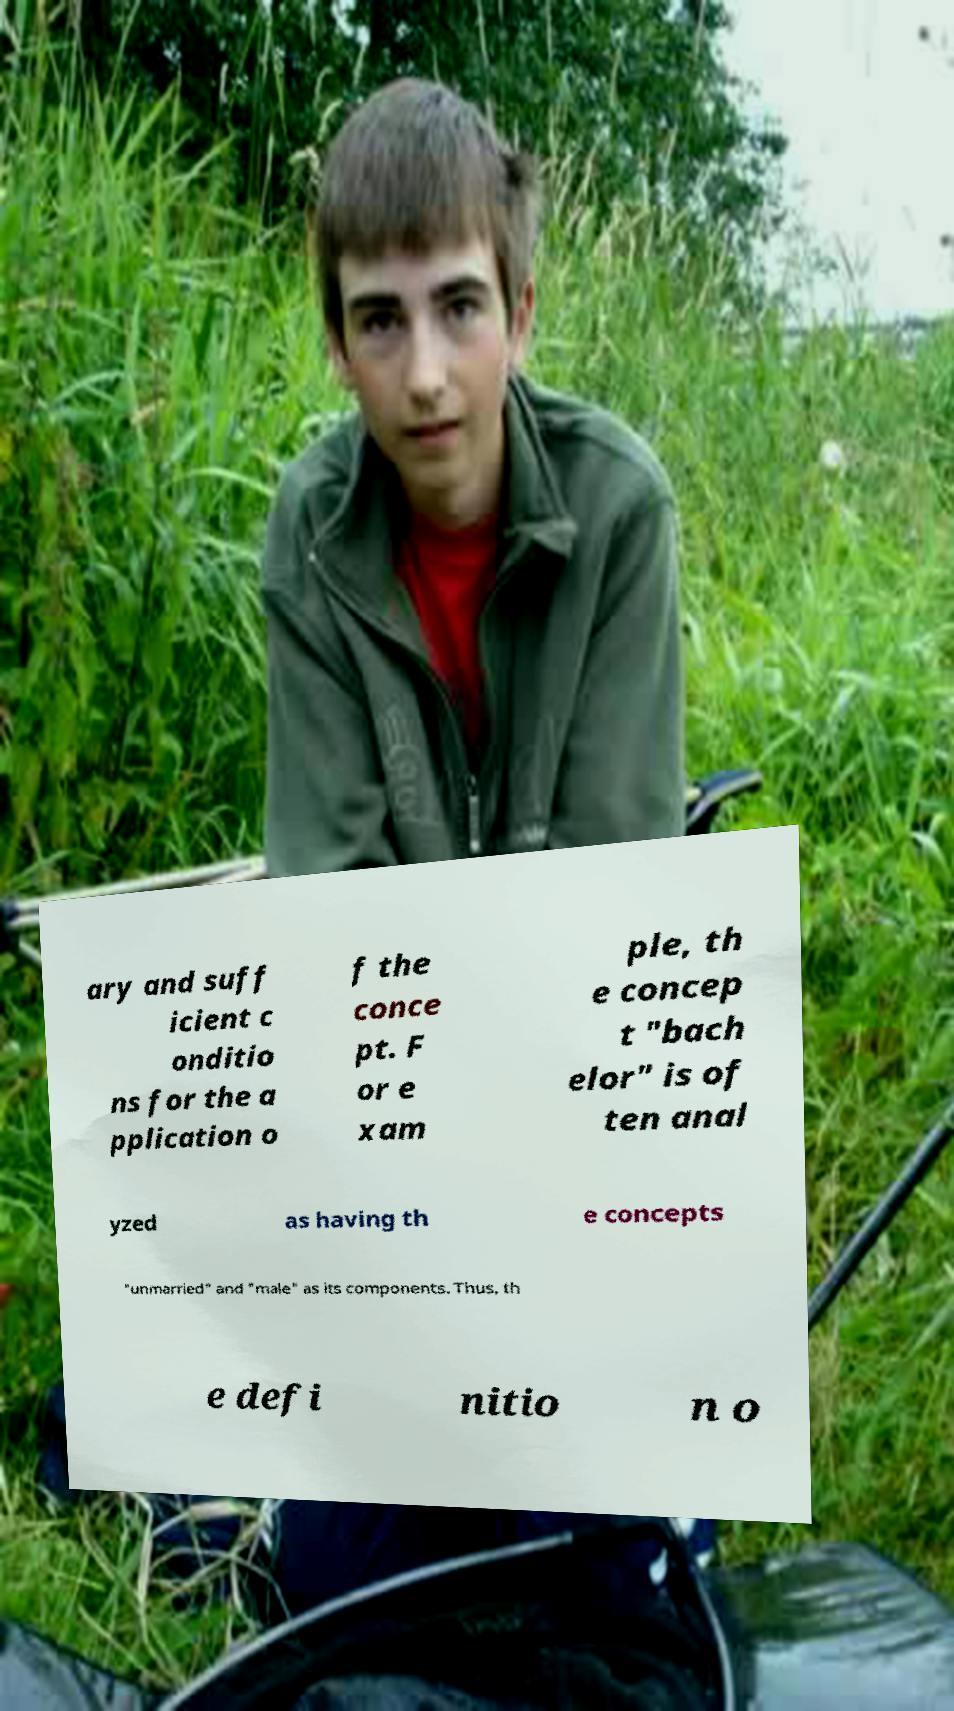I need the written content from this picture converted into text. Can you do that? ary and suff icient c onditio ns for the a pplication o f the conce pt. F or e xam ple, th e concep t "bach elor" is of ten anal yzed as having th e concepts "unmarried" and "male" as its components. Thus, th e defi nitio n o 